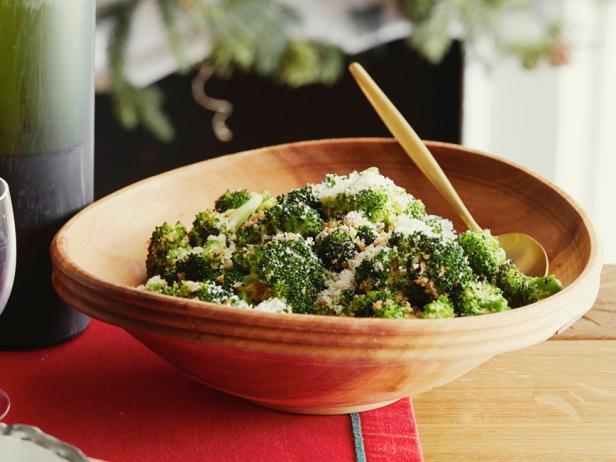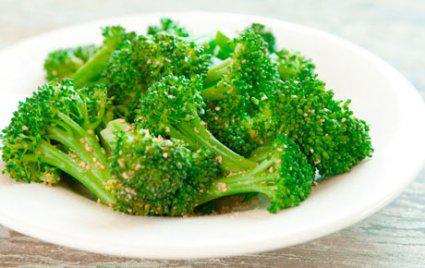The first image is the image on the left, the second image is the image on the right. For the images shown, is this caption "Everything is in white bowls." true? Answer yes or no. No. The first image is the image on the left, the second image is the image on the right. Analyze the images presented: Is the assertion "Two parallel sticks are over a round bowl containing broccoli florets in one image." valid? Answer yes or no. No. 